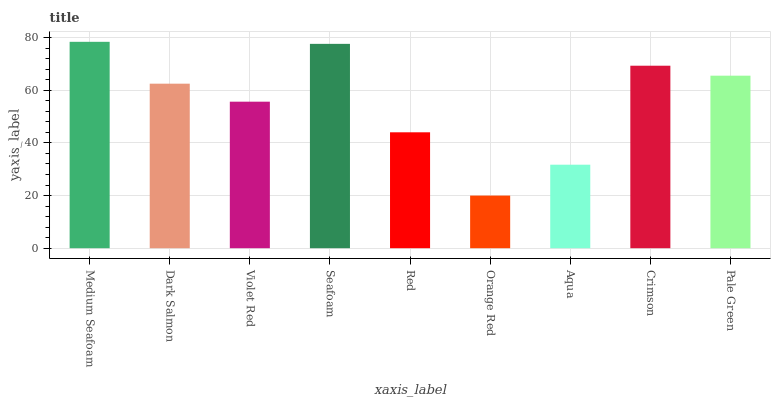Is Orange Red the minimum?
Answer yes or no. Yes. Is Medium Seafoam the maximum?
Answer yes or no. Yes. Is Dark Salmon the minimum?
Answer yes or no. No. Is Dark Salmon the maximum?
Answer yes or no. No. Is Medium Seafoam greater than Dark Salmon?
Answer yes or no. Yes. Is Dark Salmon less than Medium Seafoam?
Answer yes or no. Yes. Is Dark Salmon greater than Medium Seafoam?
Answer yes or no. No. Is Medium Seafoam less than Dark Salmon?
Answer yes or no. No. Is Dark Salmon the high median?
Answer yes or no. Yes. Is Dark Salmon the low median?
Answer yes or no. Yes. Is Medium Seafoam the high median?
Answer yes or no. No. Is Pale Green the low median?
Answer yes or no. No. 